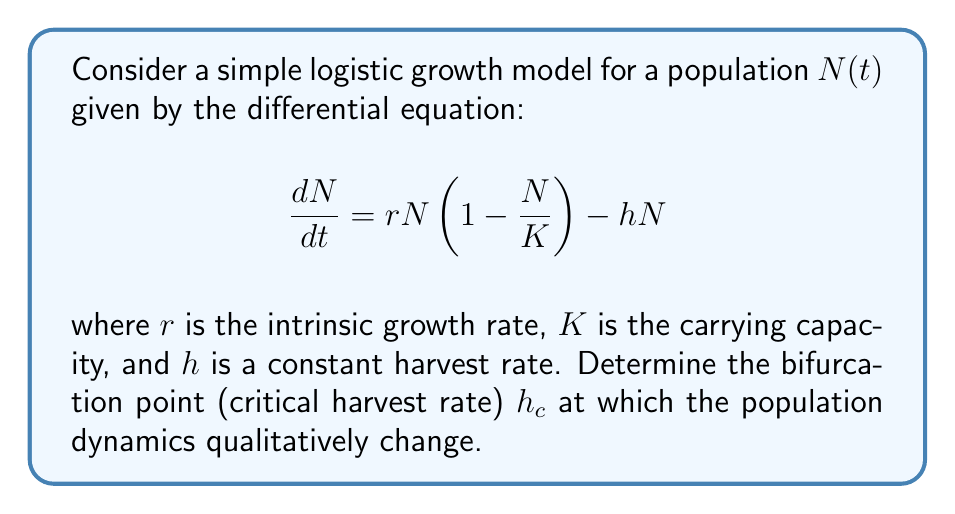Could you help me with this problem? To find the bifurcation point, we'll follow these steps:

1) First, find the equilibrium points by setting $\frac{dN}{dt} = 0$:

   $$rN(1 - \frac{N}{K}) - hN = 0$$

2) Factor out N:

   $$N(r(1 - \frac{N}{K}) - h) = 0$$

3) This gives us two equilibrium points:

   $N_1 = 0$ and $N_2 = K(1 - \frac{h}{r})$

4) The non-zero equilibrium $N_2$ exists only when $1 - \frac{h}{r} > 0$, or $h < r$.

5) The bifurcation occurs when the non-zero equilibrium coincides with the zero equilibrium, i.e., when $N_2 = 0$.

6) This happens when $1 - \frac{h}{r} = 0$, or $h = r$.

7) Therefore, the critical harvest rate $h_c = r$.

At this point, the system undergoes a transcritical bifurcation. For $h < h_c$, the non-zero equilibrium is stable and the zero equilibrium is unstable. For $h > h_c$, the zero equilibrium becomes stable, leading to population extinction.
Answer: $h_c = r$ 